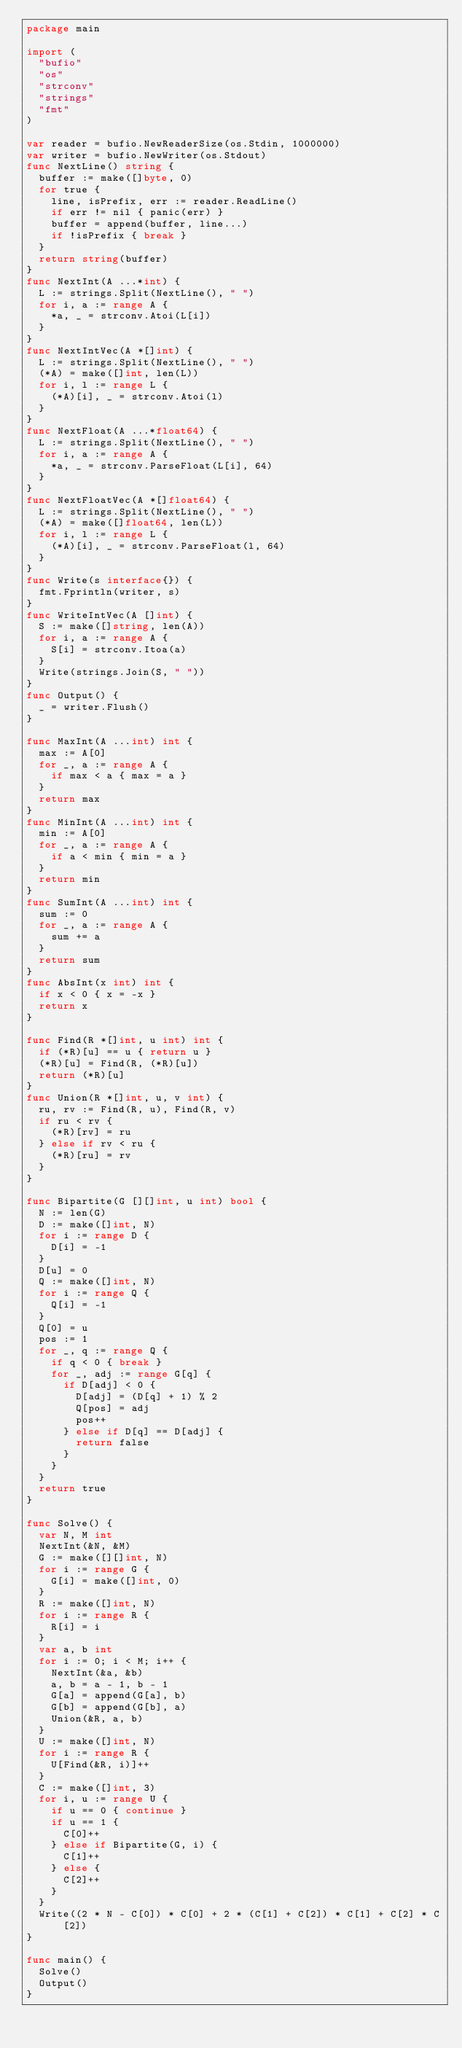<code> <loc_0><loc_0><loc_500><loc_500><_Go_>package main

import (
  "bufio"
  "os"
  "strconv"
  "strings"
  "fmt"
)

var reader = bufio.NewReaderSize(os.Stdin, 1000000)
var writer = bufio.NewWriter(os.Stdout)
func NextLine() string {
  buffer := make([]byte, 0)
  for true {
    line, isPrefix, err := reader.ReadLine()
    if err != nil { panic(err) }
    buffer = append(buffer, line...)
    if !isPrefix { break }
  }
  return string(buffer)
}
func NextInt(A ...*int) {
  L := strings.Split(NextLine(), " ")
  for i, a := range A {
    *a, _ = strconv.Atoi(L[i])
  }
}
func NextIntVec(A *[]int) {
  L := strings.Split(NextLine(), " ")
  (*A) = make([]int, len(L))
  for i, l := range L {
    (*A)[i], _ = strconv.Atoi(l)
  }
}
func NextFloat(A ...*float64) {
  L := strings.Split(NextLine(), " ")
  for i, a := range A {
    *a, _ = strconv.ParseFloat(L[i], 64)
  }
}
func NextFloatVec(A *[]float64) {
  L := strings.Split(NextLine(), " ")
  (*A) = make([]float64, len(L))
  for i, l := range L {
    (*A)[i], _ = strconv.ParseFloat(l, 64)
  }
}
func Write(s interface{}) {
  fmt.Fprintln(writer, s)
}
func WriteIntVec(A []int) {
  S := make([]string, len(A))
  for i, a := range A {
    S[i] = strconv.Itoa(a)
  }
  Write(strings.Join(S, " "))
}
func Output() {
  _ = writer.Flush()
}

func MaxInt(A ...int) int {
  max := A[0]
  for _, a := range A {
    if max < a { max = a }
  }
  return max
}
func MinInt(A ...int) int {
  min := A[0]
  for _, a := range A {
    if a < min { min = a }
  }
  return min
}
func SumInt(A ...int) int {
  sum := 0
  for _, a := range A {
    sum += a
  }
  return sum
}
func AbsInt(x int) int {
  if x < 0 { x = -x }
  return x
}

func Find(R *[]int, u int) int {
  if (*R)[u] == u { return u }
  (*R)[u] = Find(R, (*R)[u])
  return (*R)[u]
}
func Union(R *[]int, u, v int) {
  ru, rv := Find(R, u), Find(R, v)
  if ru < rv {
    (*R)[rv] = ru
  } else if rv < ru {
    (*R)[ru] = rv
  }
}

func Bipartite(G [][]int, u int) bool {
  N := len(G)
  D := make([]int, N)
  for i := range D {
    D[i] = -1
  }
  D[u] = 0
  Q := make([]int, N)
  for i := range Q {
    Q[i] = -1
  }
  Q[0] = u
  pos := 1
  for _, q := range Q {
    if q < 0 { break }
    for _, adj := range G[q] {
      if D[adj] < 0 {
        D[adj] = (D[q] + 1) % 2
        Q[pos] = adj
        pos++
      } else if D[q] == D[adj] {
        return false
      }
    }
  }
  return true
}

func Solve() {
  var N, M int
  NextInt(&N, &M)
  G := make([][]int, N)
  for i := range G {
    G[i] = make([]int, 0)
  }
  R := make([]int, N)
  for i := range R {
    R[i] = i
  }
  var a, b int
  for i := 0; i < M; i++ {
    NextInt(&a, &b)
    a, b = a - 1, b - 1
    G[a] = append(G[a], b)
    G[b] = append(G[b], a)
    Union(&R, a, b)
  }
  U := make([]int, N)
  for i := range R {
    U[Find(&R, i)]++
  }
  C := make([]int, 3)
  for i, u := range U {
    if u == 0 { continue }
    if u == 1 {
      C[0]++
    } else if Bipartite(G, i) {
      C[1]++
    } else {
      C[2]++
    }
  }
  Write((2 * N - C[0]) * C[0] + 2 * (C[1] + C[2]) * C[1] + C[2] * C[2])
}

func main() {
  Solve()
  Output()
}</code> 